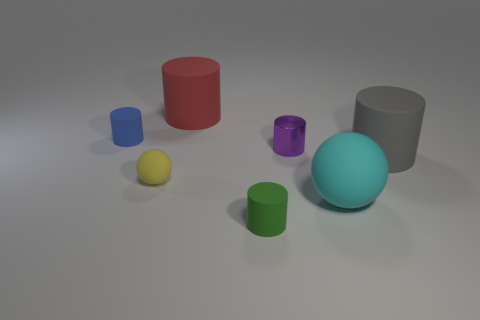Subtract all cyan cylinders. Subtract all purple blocks. How many cylinders are left? 5 Add 1 big rubber spheres. How many objects exist? 8 Subtract all spheres. How many objects are left? 5 Subtract all small spheres. Subtract all large cyan balls. How many objects are left? 5 Add 4 tiny matte objects. How many tiny matte objects are left? 7 Add 4 cyan balls. How many cyan balls exist? 5 Subtract 0 yellow cubes. How many objects are left? 7 